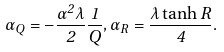<formula> <loc_0><loc_0><loc_500><loc_500>\alpha _ { Q } = - \frac { \alpha ^ { 2 } \lambda } { 2 } \frac { 1 } { Q } , \alpha _ { R } = \frac { \lambda \tanh R } { 4 } .</formula> 